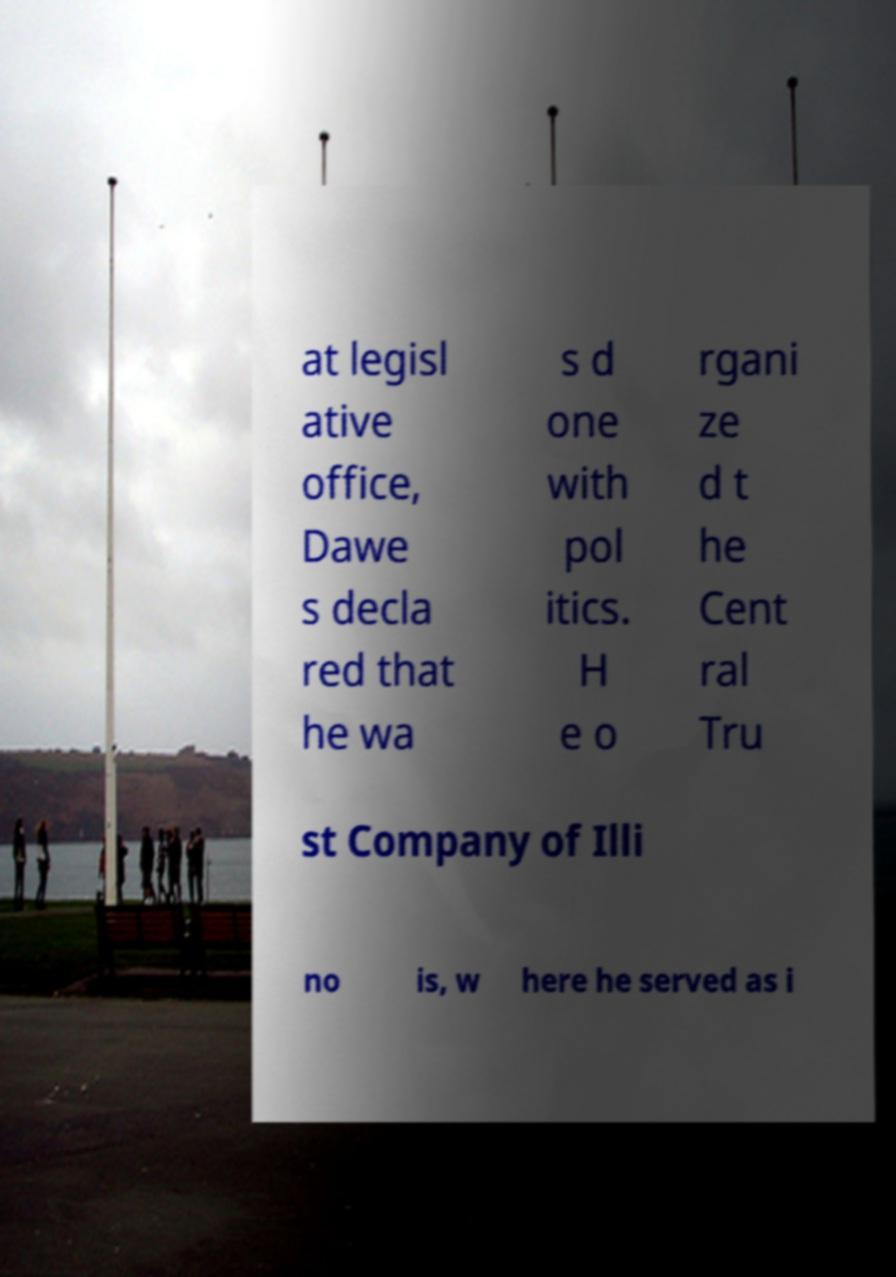Can you read and provide the text displayed in the image?This photo seems to have some interesting text. Can you extract and type it out for me? at legisl ative office, Dawe s decla red that he wa s d one with pol itics. H e o rgani ze d t he Cent ral Tru st Company of Illi no is, w here he served as i 